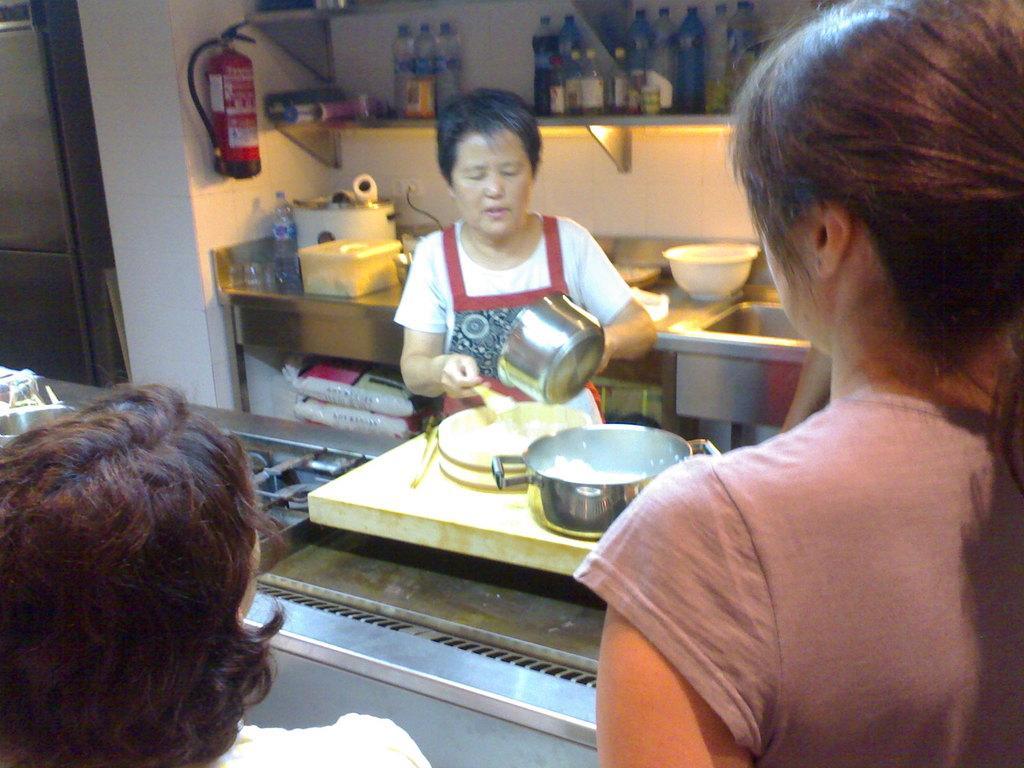Could you give a brief overview of what you see in this image? In this image there are two persons are standing at bottom of this image. On person is standing in middle of this image is wearing white color t shirt and holding a steel bowl and one spoon and there is a stove in middle of this image and there is a counter top at middle of this image and there are some objects kept on it. There is a door at left side of this image. There are some bottles are kept on some rack at top of this image. 